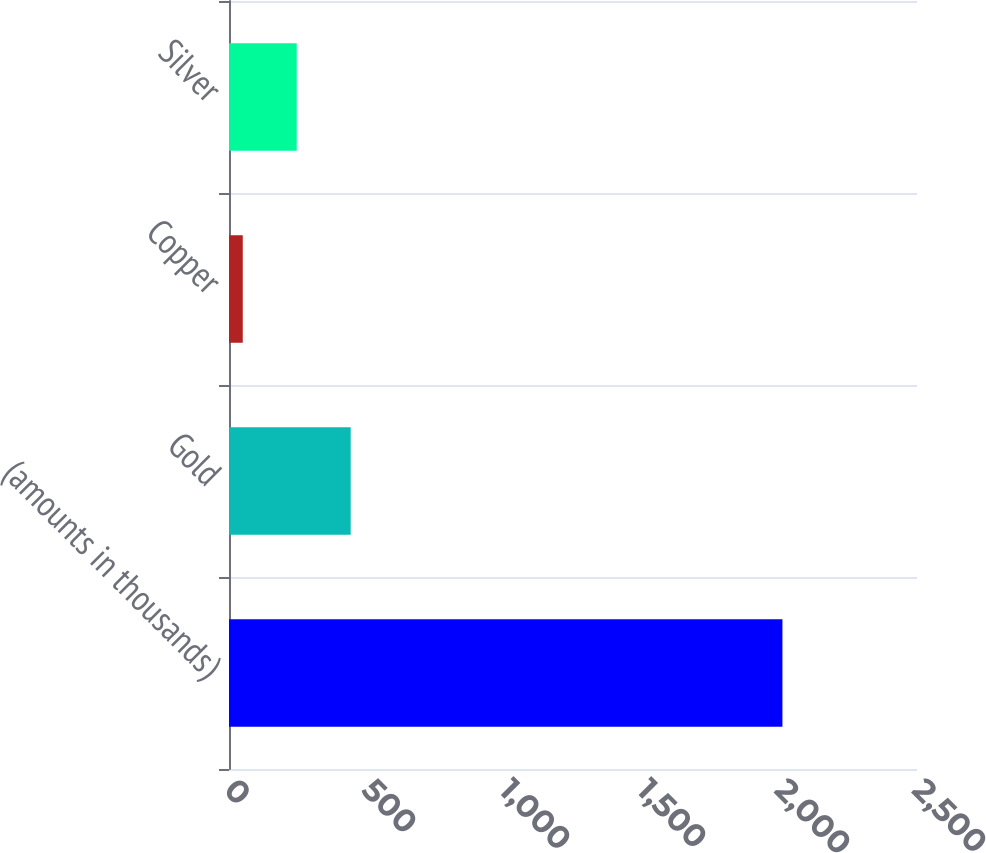Convert chart. <chart><loc_0><loc_0><loc_500><loc_500><bar_chart><fcel>(amounts in thousands)<fcel>Gold<fcel>Copper<fcel>Silver<nl><fcel>2011<fcel>442.2<fcel>50<fcel>246.1<nl></chart> 